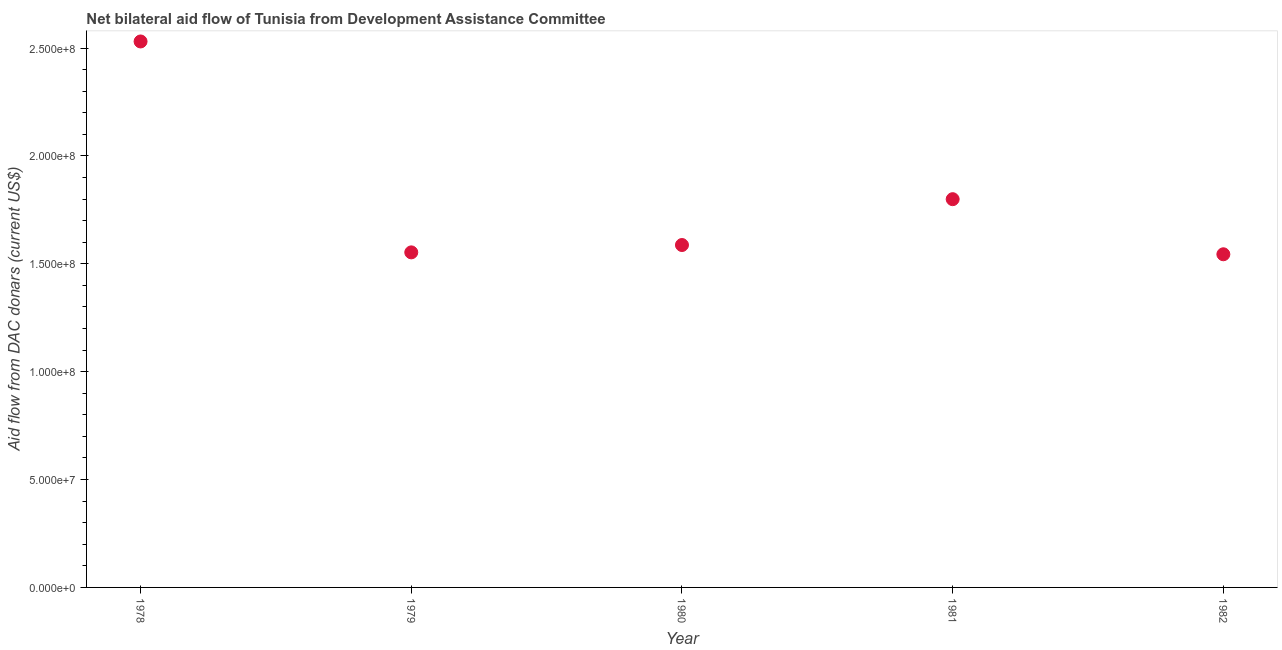What is the net bilateral aid flows from dac donors in 1981?
Offer a terse response. 1.80e+08. Across all years, what is the maximum net bilateral aid flows from dac donors?
Provide a succinct answer. 2.53e+08. Across all years, what is the minimum net bilateral aid flows from dac donors?
Provide a short and direct response. 1.54e+08. In which year was the net bilateral aid flows from dac donors maximum?
Your response must be concise. 1978. In which year was the net bilateral aid flows from dac donors minimum?
Provide a short and direct response. 1982. What is the sum of the net bilateral aid flows from dac donors?
Give a very brief answer. 9.02e+08. What is the difference between the net bilateral aid flows from dac donors in 1978 and 1979?
Your answer should be very brief. 9.78e+07. What is the average net bilateral aid flows from dac donors per year?
Give a very brief answer. 1.80e+08. What is the median net bilateral aid flows from dac donors?
Keep it short and to the point. 1.59e+08. In how many years, is the net bilateral aid flows from dac donors greater than 90000000 US$?
Your response must be concise. 5. What is the ratio of the net bilateral aid flows from dac donors in 1978 to that in 1981?
Ensure brevity in your answer.  1.41. Is the net bilateral aid flows from dac donors in 1978 less than that in 1982?
Provide a succinct answer. No. What is the difference between the highest and the second highest net bilateral aid flows from dac donors?
Your answer should be compact. 7.31e+07. Is the sum of the net bilateral aid flows from dac donors in 1981 and 1982 greater than the maximum net bilateral aid flows from dac donors across all years?
Keep it short and to the point. Yes. What is the difference between the highest and the lowest net bilateral aid flows from dac donors?
Offer a very short reply. 9.86e+07. How many years are there in the graph?
Offer a terse response. 5. Does the graph contain any zero values?
Provide a succinct answer. No. Does the graph contain grids?
Offer a very short reply. No. What is the title of the graph?
Keep it short and to the point. Net bilateral aid flow of Tunisia from Development Assistance Committee. What is the label or title of the Y-axis?
Offer a very short reply. Aid flow from DAC donars (current US$). What is the Aid flow from DAC donars (current US$) in 1978?
Ensure brevity in your answer.  2.53e+08. What is the Aid flow from DAC donars (current US$) in 1979?
Offer a very short reply. 1.55e+08. What is the Aid flow from DAC donars (current US$) in 1980?
Make the answer very short. 1.59e+08. What is the Aid flow from DAC donars (current US$) in 1981?
Provide a succinct answer. 1.80e+08. What is the Aid flow from DAC donars (current US$) in 1982?
Provide a short and direct response. 1.54e+08. What is the difference between the Aid flow from DAC donars (current US$) in 1978 and 1979?
Your response must be concise. 9.78e+07. What is the difference between the Aid flow from DAC donars (current US$) in 1978 and 1980?
Offer a very short reply. 9.44e+07. What is the difference between the Aid flow from DAC donars (current US$) in 1978 and 1981?
Provide a short and direct response. 7.31e+07. What is the difference between the Aid flow from DAC donars (current US$) in 1978 and 1982?
Give a very brief answer. 9.86e+07. What is the difference between the Aid flow from DAC donars (current US$) in 1979 and 1980?
Offer a very short reply. -3.41e+06. What is the difference between the Aid flow from DAC donars (current US$) in 1979 and 1981?
Make the answer very short. -2.47e+07. What is the difference between the Aid flow from DAC donars (current US$) in 1979 and 1982?
Provide a succinct answer. 8.80e+05. What is the difference between the Aid flow from DAC donars (current US$) in 1980 and 1981?
Provide a succinct answer. -2.12e+07. What is the difference between the Aid flow from DAC donars (current US$) in 1980 and 1982?
Your answer should be very brief. 4.29e+06. What is the difference between the Aid flow from DAC donars (current US$) in 1981 and 1982?
Make the answer very short. 2.55e+07. What is the ratio of the Aid flow from DAC donars (current US$) in 1978 to that in 1979?
Your answer should be very brief. 1.63. What is the ratio of the Aid flow from DAC donars (current US$) in 1978 to that in 1980?
Provide a short and direct response. 1.59. What is the ratio of the Aid flow from DAC donars (current US$) in 1978 to that in 1981?
Your answer should be very brief. 1.41. What is the ratio of the Aid flow from DAC donars (current US$) in 1978 to that in 1982?
Offer a terse response. 1.64. What is the ratio of the Aid flow from DAC donars (current US$) in 1979 to that in 1981?
Give a very brief answer. 0.86. What is the ratio of the Aid flow from DAC donars (current US$) in 1979 to that in 1982?
Provide a short and direct response. 1.01. What is the ratio of the Aid flow from DAC donars (current US$) in 1980 to that in 1981?
Ensure brevity in your answer.  0.88. What is the ratio of the Aid flow from DAC donars (current US$) in 1980 to that in 1982?
Your answer should be compact. 1.03. What is the ratio of the Aid flow from DAC donars (current US$) in 1981 to that in 1982?
Ensure brevity in your answer.  1.17. 